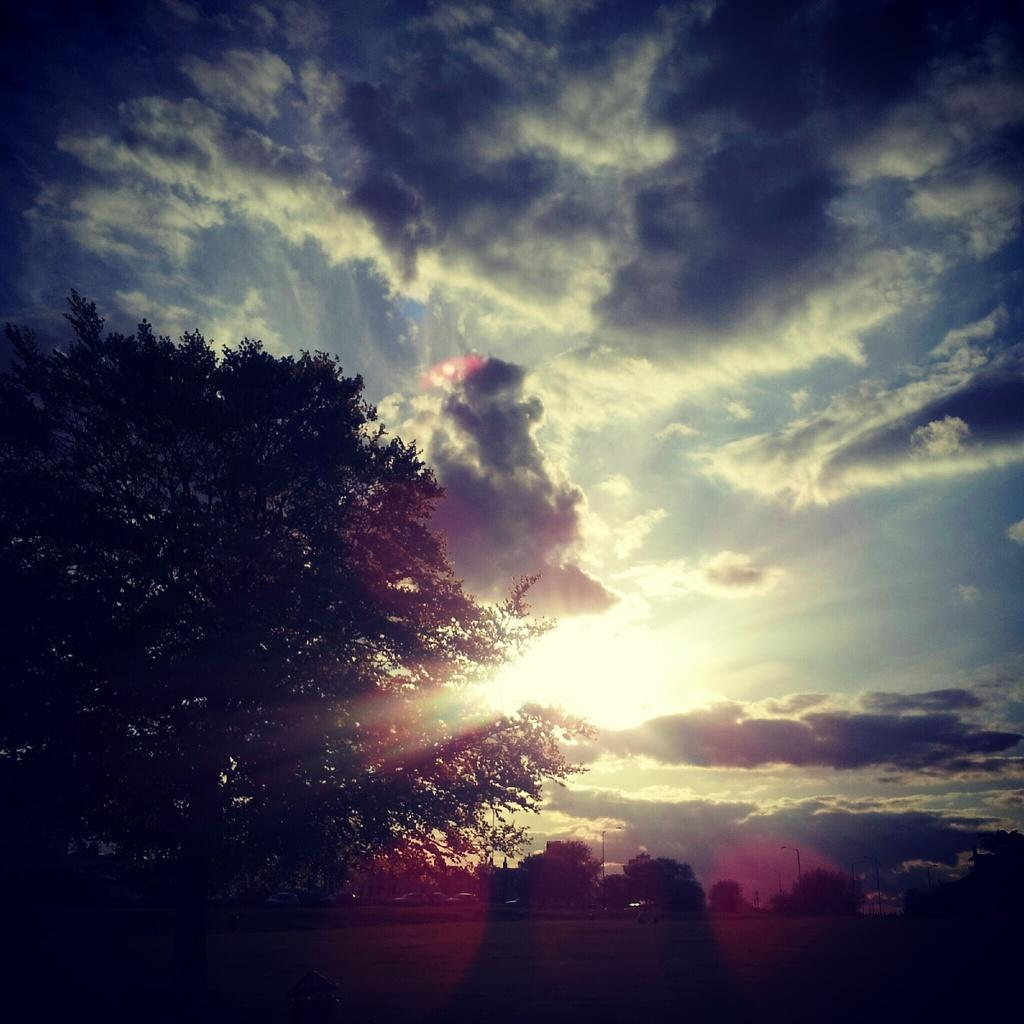What type of vegetation is visible in the image? There are trees in the image. What type of structures are present in the image? There are light poles in the image. What part of the natural environment is visible in the image? The sky is visible in the image. From where might the image have been taken? The image was likely taken from the ground. What type of low print is visible on the government building in the image? There is no government building present in the image, and therefore no low print can be observed. 